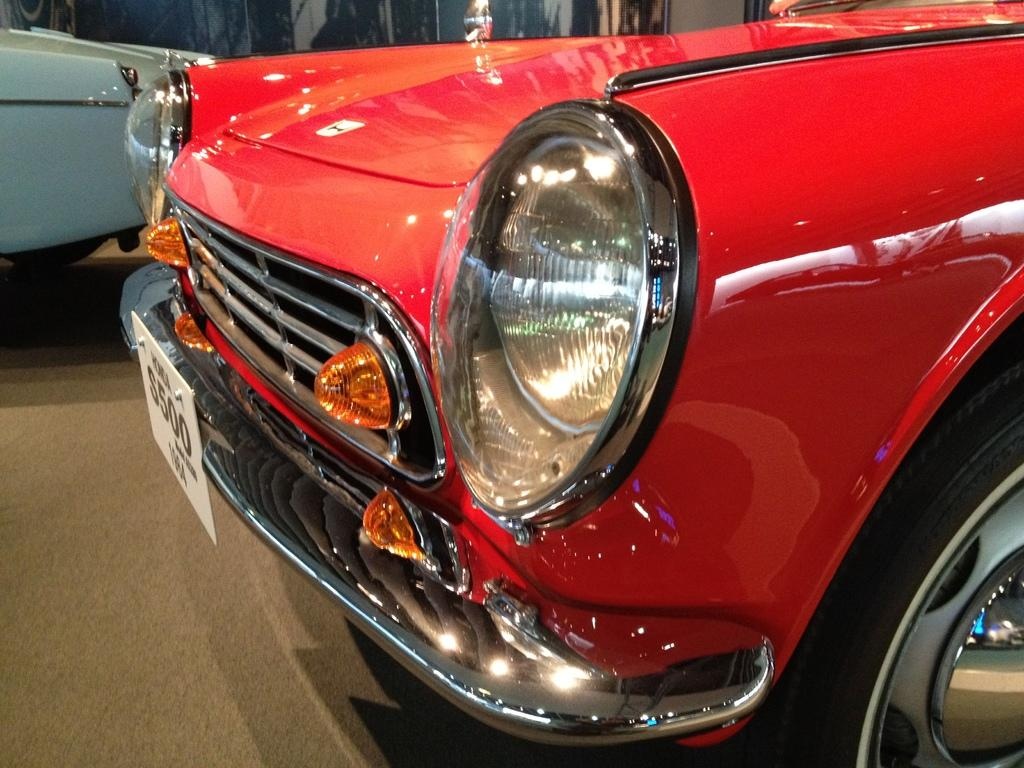What part of a car is visible in the image? The front part of a car is visible in the image. What features can be seen on the car? The car has headlights, a bumper, a number plate, and a tire. Can you describe the car's surroundings in the image? There is another car in the background of the image. What type of coast can be seen near the car in the image? There is no coast visible in the image; it shows the front part of a car and another car in the background. 